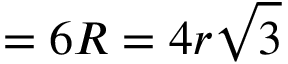Convert formula to latex. <formula><loc_0><loc_0><loc_500><loc_500>{ } = 6 R = 4 r { \sqrt { 3 } }</formula> 